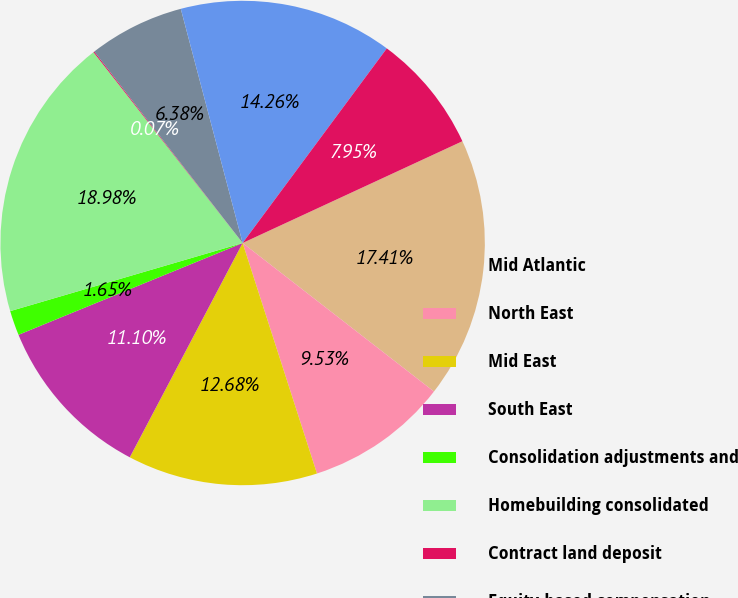<chart> <loc_0><loc_0><loc_500><loc_500><pie_chart><fcel>Mid Atlantic<fcel>North East<fcel>Mid East<fcel>South East<fcel>Consolidation adjustments and<fcel>Homebuilding consolidated<fcel>Contract land deposit<fcel>Equity-based compensation<fcel>Corporate capital allocation<fcel>Unallocated corporate overhead<nl><fcel>17.41%<fcel>9.53%<fcel>12.68%<fcel>11.1%<fcel>1.65%<fcel>18.98%<fcel>0.07%<fcel>6.38%<fcel>14.26%<fcel>7.95%<nl></chart> 